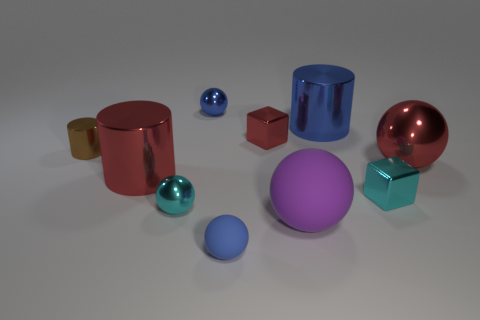There is another object that is the same shape as the tiny red thing; what is its size? small 